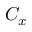<formula> <loc_0><loc_0><loc_500><loc_500>C _ { x }</formula> 